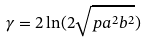Convert formula to latex. <formula><loc_0><loc_0><loc_500><loc_500>\gamma = 2 \ln ( 2 \sqrt { p a ^ { 2 } b ^ { 2 } } )</formula> 